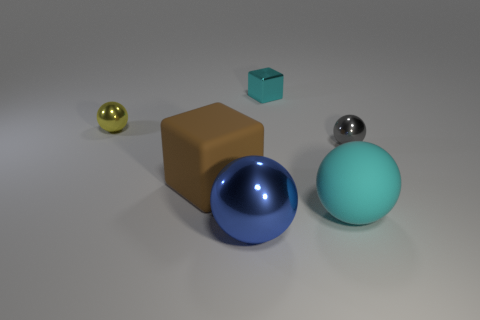Subtract all gray spheres. How many spheres are left? 3 Subtract all purple balls. Subtract all blue blocks. How many balls are left? 4 Add 2 shiny things. How many objects exist? 8 Subtract all cubes. How many objects are left? 4 Add 1 small objects. How many small objects exist? 4 Subtract 0 yellow cylinders. How many objects are left? 6 Subtract all gray objects. Subtract all metallic balls. How many objects are left? 2 Add 3 large brown things. How many large brown things are left? 4 